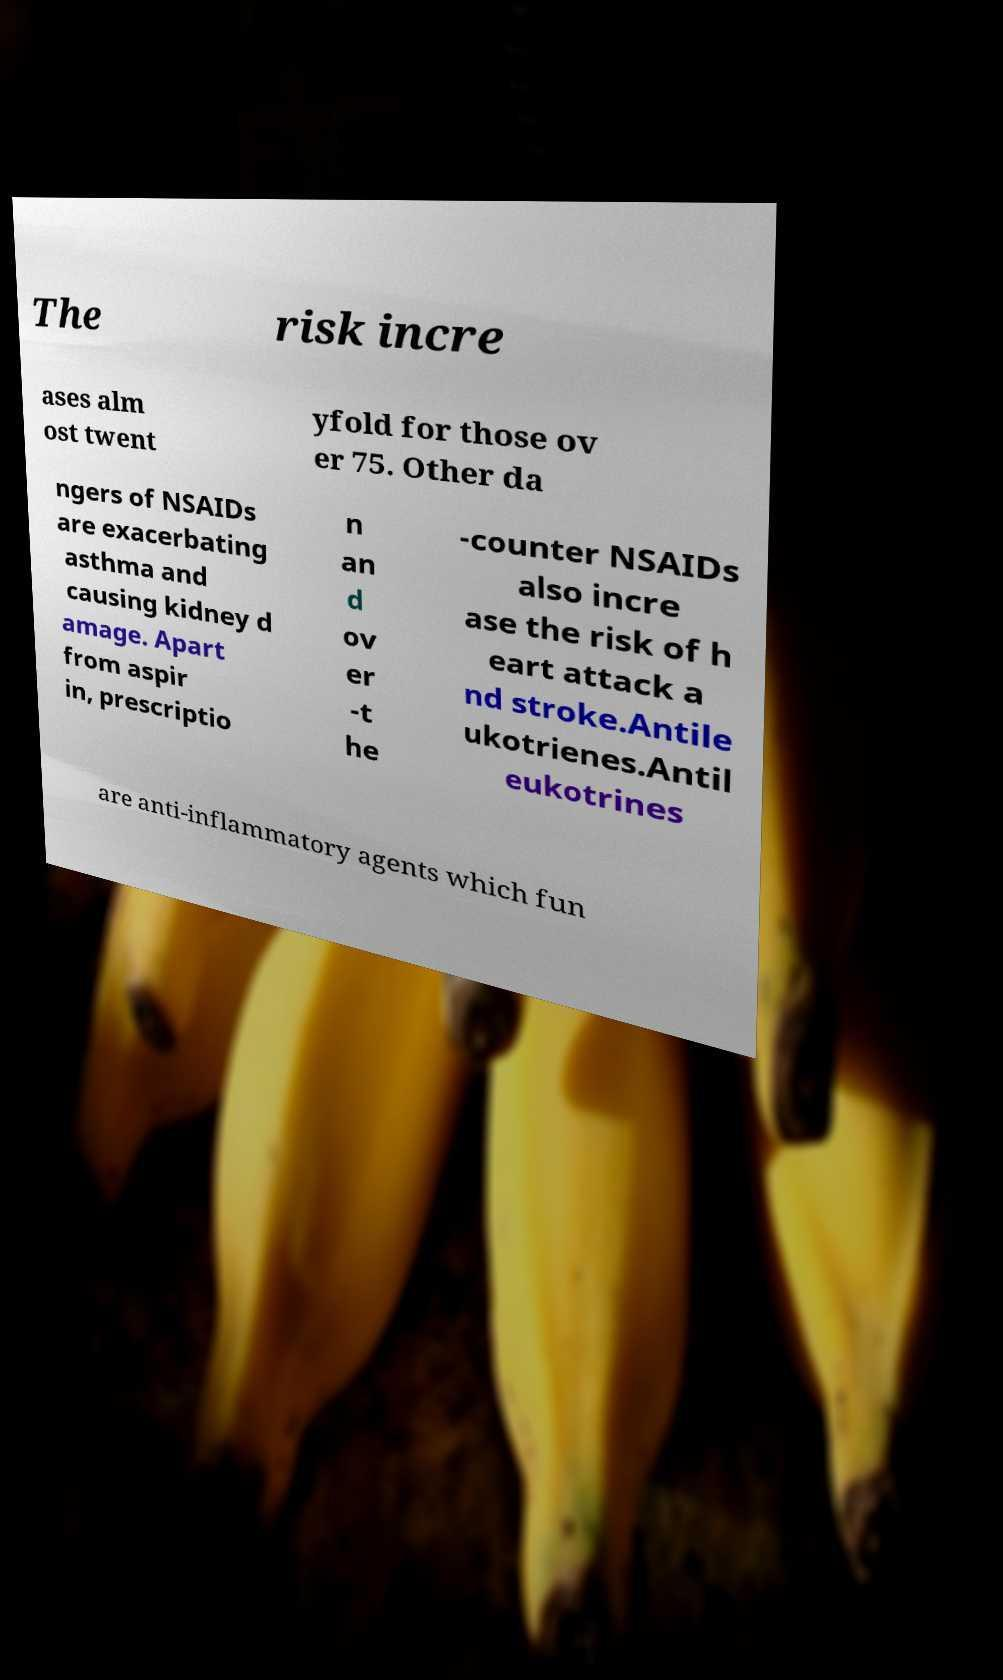Can you read and provide the text displayed in the image?This photo seems to have some interesting text. Can you extract and type it out for me? The risk incre ases alm ost twent yfold for those ov er 75. Other da ngers of NSAIDs are exacerbating asthma and causing kidney d amage. Apart from aspir in, prescriptio n an d ov er -t he -counter NSAIDs also incre ase the risk of h eart attack a nd stroke.Antile ukotrienes.Antil eukotrines are anti-inflammatory agents which fun 